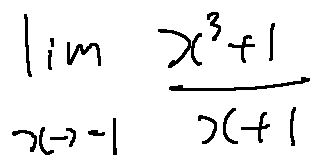Convert formula to latex. <formula><loc_0><loc_0><loc_500><loc_500>\lim \lim i t s _ { x \rightarrow - 1 } \frac { x ^ { 3 } + 1 } { x + 1 }</formula> 